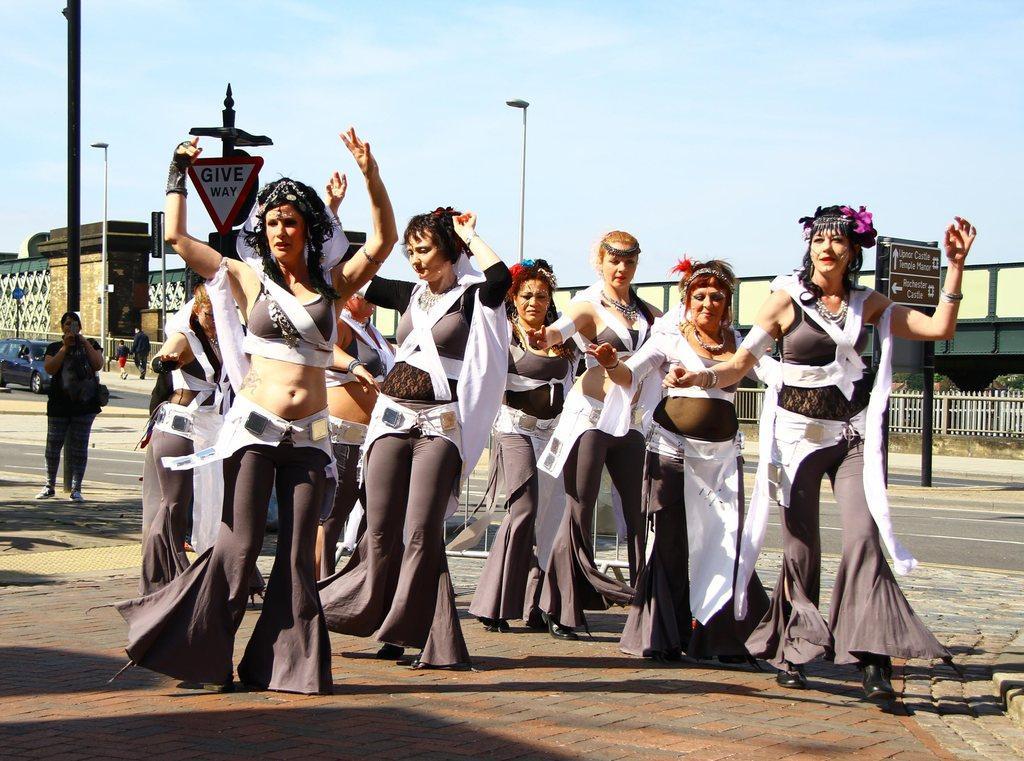In one or two sentences, can you explain what this image depicts? In the image I can see some women who are wearing same dress and behind there are some buildings and also I can see some poles and trees and boards. 